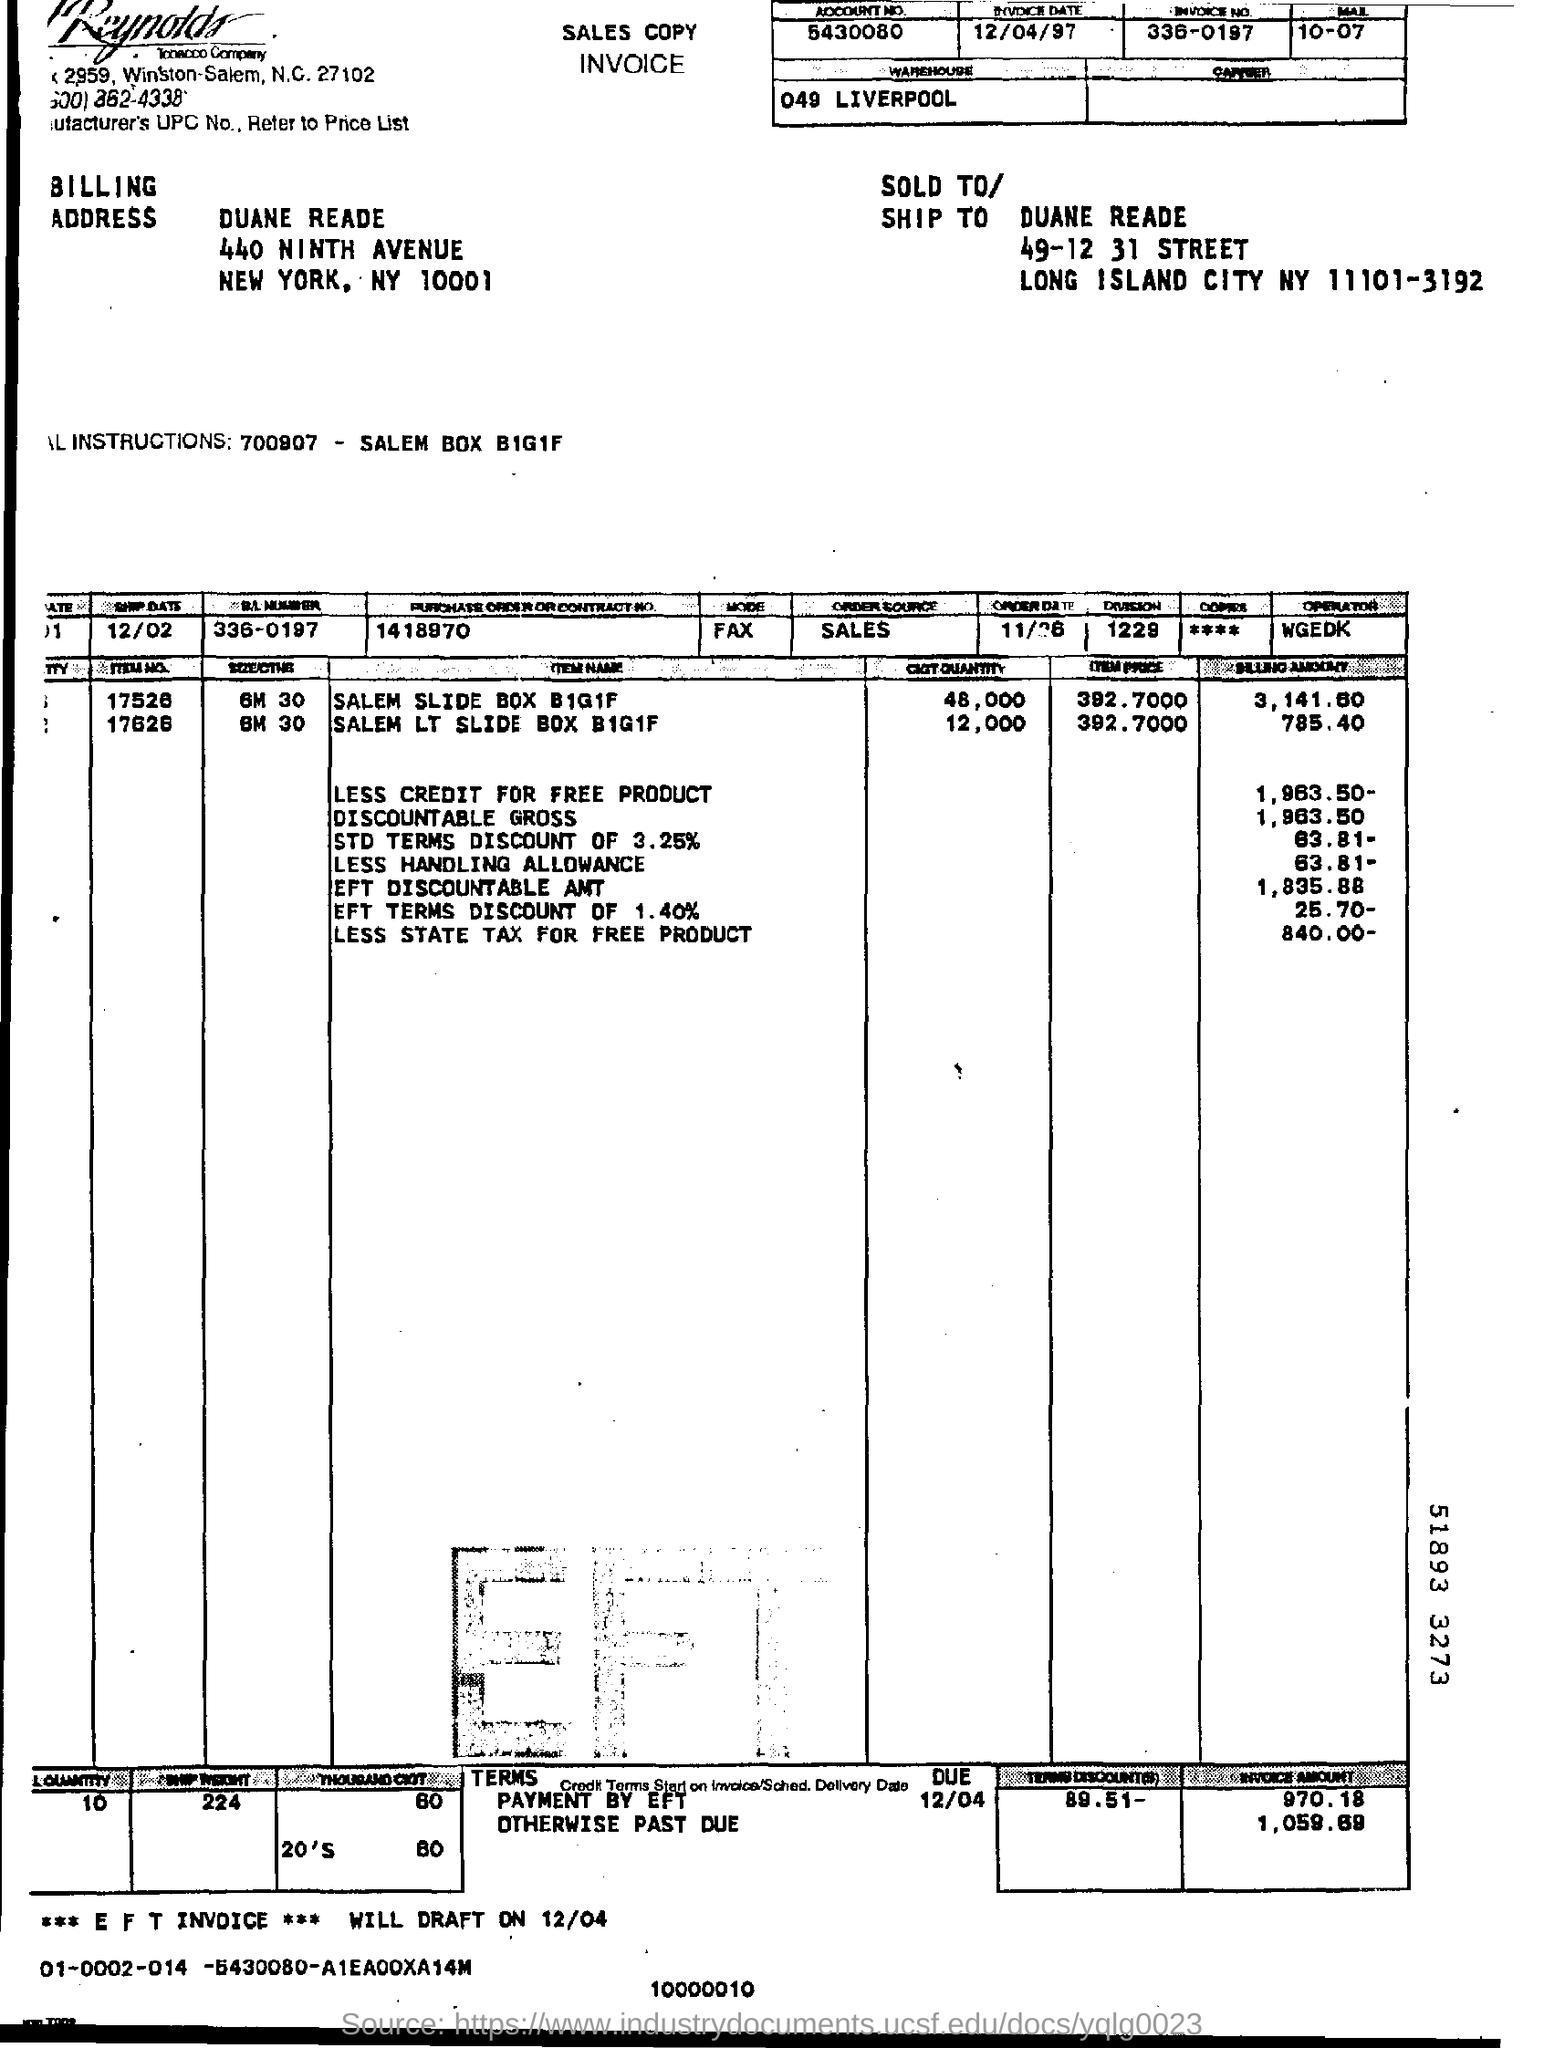Mention a couple of crucial points in this snapshot. What is the division number? It is 1229. 